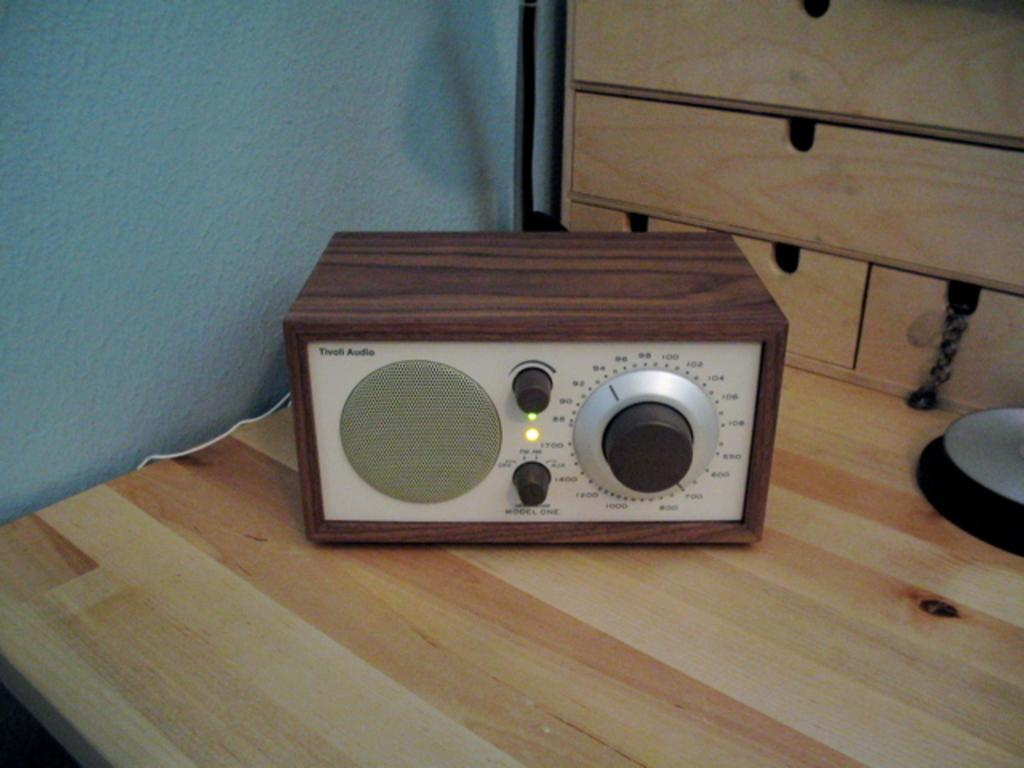What type of equipment is visible in the image? There is an audio equipment in the image. Where is the audio equipment located? The audio equipment is present on a table. What type of shoes are visible in the image? There are no shoes present in the image. 